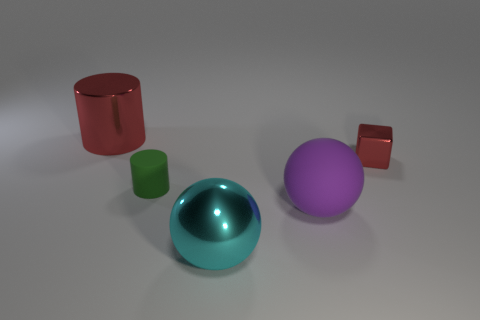Add 1 cylinders. How many objects exist? 6 Subtract all balls. How many objects are left? 3 Add 3 tiny matte objects. How many tiny matte objects are left? 4 Add 5 small brown cubes. How many small brown cubes exist? 5 Subtract 0 blue balls. How many objects are left? 5 Subtract all green matte things. Subtract all small matte cylinders. How many objects are left? 3 